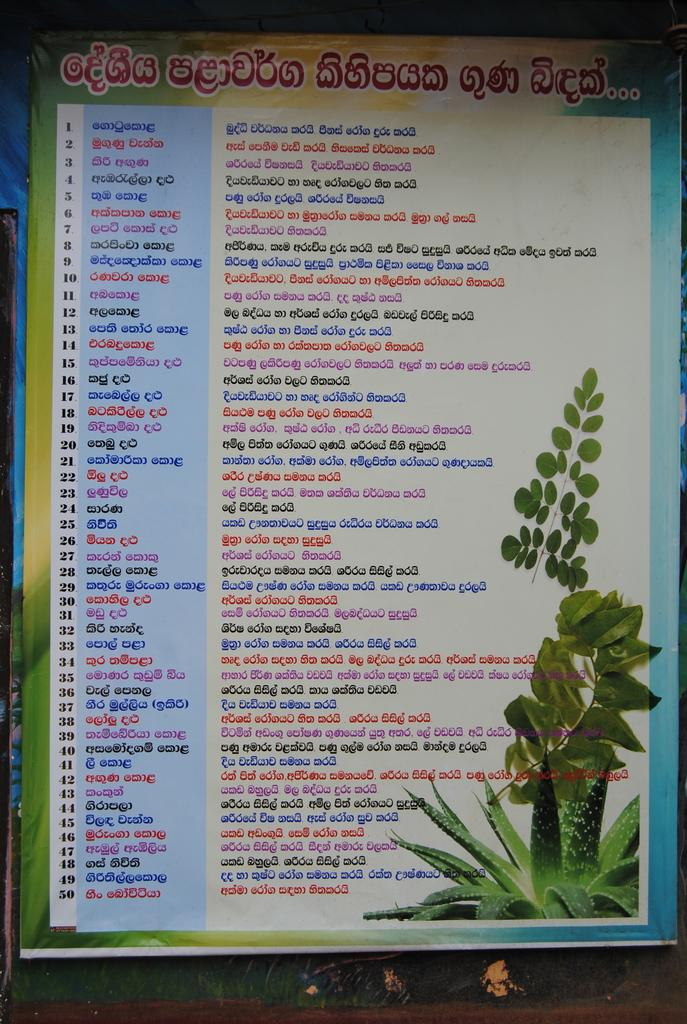What is hanging in the image? There is a banner in the image. What can be read on the banner? The banner has text on it. What type of natural elements can be seen in the image? There are leaves visible in the image. What is related to plants in the image? There is a plant image in the image. How many balloons are tied to the banner in the image? There are no balloons present in the image; only the banner, text, leaves, and plant image can be seen. 